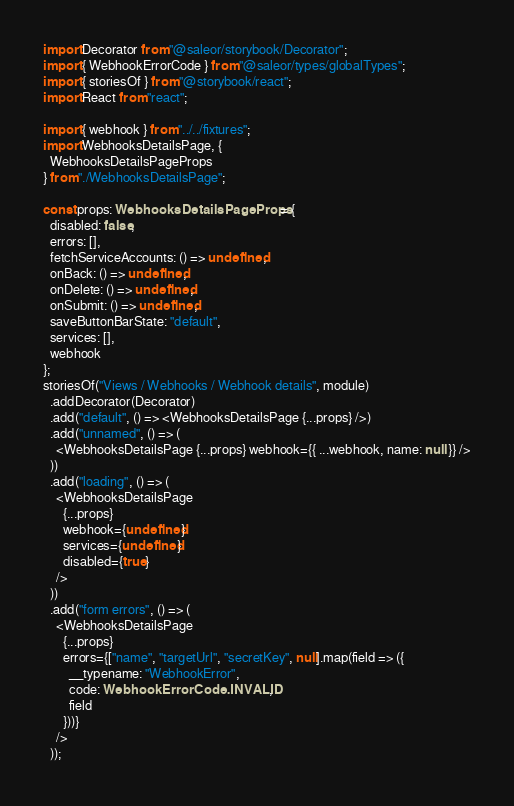Convert code to text. <code><loc_0><loc_0><loc_500><loc_500><_TypeScript_>import Decorator from "@saleor/storybook/Decorator";
import { WebhookErrorCode } from "@saleor/types/globalTypes";
import { storiesOf } from "@storybook/react";
import React from "react";

import { webhook } from "../../fixtures";
import WebhooksDetailsPage, {
  WebhooksDetailsPageProps
} from "./WebhooksDetailsPage";

const props: WebhooksDetailsPageProps = {
  disabled: false,
  errors: [],
  fetchServiceAccounts: () => undefined,
  onBack: () => undefined,
  onDelete: () => undefined,
  onSubmit: () => undefined,
  saveButtonBarState: "default",
  services: [],
  webhook
};
storiesOf("Views / Webhooks / Webhook details", module)
  .addDecorator(Decorator)
  .add("default", () => <WebhooksDetailsPage {...props} />)
  .add("unnamed", () => (
    <WebhooksDetailsPage {...props} webhook={{ ...webhook, name: null }} />
  ))
  .add("loading", () => (
    <WebhooksDetailsPage
      {...props}
      webhook={undefined}
      services={undefined}
      disabled={true}
    />
  ))
  .add("form errors", () => (
    <WebhooksDetailsPage
      {...props}
      errors={["name", "targetUrl", "secretKey", null].map(field => ({
        __typename: "WebhookError",
        code: WebhookErrorCode.INVALID,
        field
      }))}
    />
  ));
</code> 